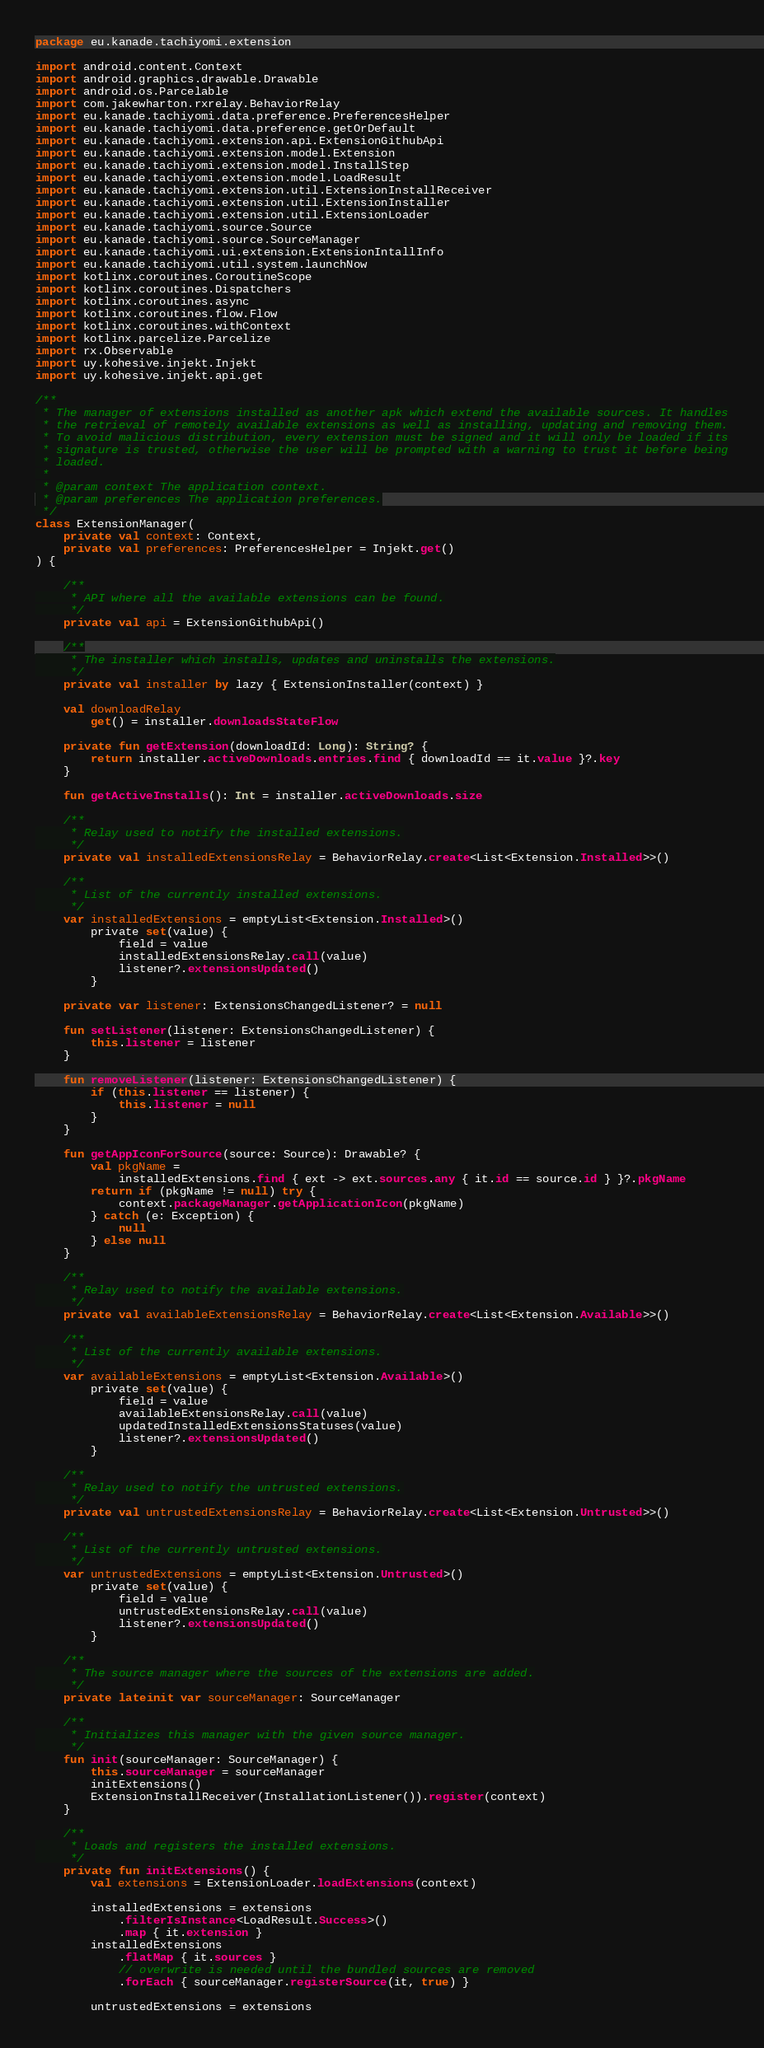<code> <loc_0><loc_0><loc_500><loc_500><_Kotlin_>package eu.kanade.tachiyomi.extension

import android.content.Context
import android.graphics.drawable.Drawable
import android.os.Parcelable
import com.jakewharton.rxrelay.BehaviorRelay
import eu.kanade.tachiyomi.data.preference.PreferencesHelper
import eu.kanade.tachiyomi.data.preference.getOrDefault
import eu.kanade.tachiyomi.extension.api.ExtensionGithubApi
import eu.kanade.tachiyomi.extension.model.Extension
import eu.kanade.tachiyomi.extension.model.InstallStep
import eu.kanade.tachiyomi.extension.model.LoadResult
import eu.kanade.tachiyomi.extension.util.ExtensionInstallReceiver
import eu.kanade.tachiyomi.extension.util.ExtensionInstaller
import eu.kanade.tachiyomi.extension.util.ExtensionLoader
import eu.kanade.tachiyomi.source.Source
import eu.kanade.tachiyomi.source.SourceManager
import eu.kanade.tachiyomi.ui.extension.ExtensionIntallInfo
import eu.kanade.tachiyomi.util.system.launchNow
import kotlinx.coroutines.CoroutineScope
import kotlinx.coroutines.Dispatchers
import kotlinx.coroutines.async
import kotlinx.coroutines.flow.Flow
import kotlinx.coroutines.withContext
import kotlinx.parcelize.Parcelize
import rx.Observable
import uy.kohesive.injekt.Injekt
import uy.kohesive.injekt.api.get

/**
 * The manager of extensions installed as another apk which extend the available sources. It handles
 * the retrieval of remotely available extensions as well as installing, updating and removing them.
 * To avoid malicious distribution, every extension must be signed and it will only be loaded if its
 * signature is trusted, otherwise the user will be prompted with a warning to trust it before being
 * loaded.
 *
 * @param context The application context.
 * @param preferences The application preferences.
 */
class ExtensionManager(
    private val context: Context,
    private val preferences: PreferencesHelper = Injekt.get()
) {

    /**
     * API where all the available extensions can be found.
     */
    private val api = ExtensionGithubApi()

    /**
     * The installer which installs, updates and uninstalls the extensions.
     */
    private val installer by lazy { ExtensionInstaller(context) }

    val downloadRelay
        get() = installer.downloadsStateFlow

    private fun getExtension(downloadId: Long): String? {
        return installer.activeDownloads.entries.find { downloadId == it.value }?.key
    }

    fun getActiveInstalls(): Int = installer.activeDownloads.size

    /**
     * Relay used to notify the installed extensions.
     */
    private val installedExtensionsRelay = BehaviorRelay.create<List<Extension.Installed>>()

    /**
     * List of the currently installed extensions.
     */
    var installedExtensions = emptyList<Extension.Installed>()
        private set(value) {
            field = value
            installedExtensionsRelay.call(value)
            listener?.extensionsUpdated()
        }

    private var listener: ExtensionsChangedListener? = null

    fun setListener(listener: ExtensionsChangedListener) {
        this.listener = listener
    }

    fun removeListener(listener: ExtensionsChangedListener) {
        if (this.listener == listener) {
            this.listener = null
        }
    }

    fun getAppIconForSource(source: Source): Drawable? {
        val pkgName =
            installedExtensions.find { ext -> ext.sources.any { it.id == source.id } }?.pkgName
        return if (pkgName != null) try {
            context.packageManager.getApplicationIcon(pkgName)
        } catch (e: Exception) {
            null
        } else null
    }

    /**
     * Relay used to notify the available extensions.
     */
    private val availableExtensionsRelay = BehaviorRelay.create<List<Extension.Available>>()

    /**
     * List of the currently available extensions.
     */
    var availableExtensions = emptyList<Extension.Available>()
        private set(value) {
            field = value
            availableExtensionsRelay.call(value)
            updatedInstalledExtensionsStatuses(value)
            listener?.extensionsUpdated()
        }

    /**
     * Relay used to notify the untrusted extensions.
     */
    private val untrustedExtensionsRelay = BehaviorRelay.create<List<Extension.Untrusted>>()

    /**
     * List of the currently untrusted extensions.
     */
    var untrustedExtensions = emptyList<Extension.Untrusted>()
        private set(value) {
            field = value
            untrustedExtensionsRelay.call(value)
            listener?.extensionsUpdated()
        }

    /**
     * The source manager where the sources of the extensions are added.
     */
    private lateinit var sourceManager: SourceManager

    /**
     * Initializes this manager with the given source manager.
     */
    fun init(sourceManager: SourceManager) {
        this.sourceManager = sourceManager
        initExtensions()
        ExtensionInstallReceiver(InstallationListener()).register(context)
    }

    /**
     * Loads and registers the installed extensions.
     */
    private fun initExtensions() {
        val extensions = ExtensionLoader.loadExtensions(context)

        installedExtensions = extensions
            .filterIsInstance<LoadResult.Success>()
            .map { it.extension }
        installedExtensions
            .flatMap { it.sources }
            // overwrite is needed until the bundled sources are removed
            .forEach { sourceManager.registerSource(it, true) }

        untrustedExtensions = extensions</code> 